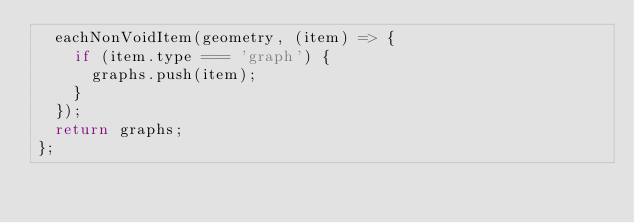<code> <loc_0><loc_0><loc_500><loc_500><_JavaScript_>  eachNonVoidItem(geometry, (item) => {
    if (item.type === 'graph') {
      graphs.push(item);
    }
  });
  return graphs;
};
</code> 